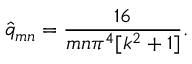<formula> <loc_0><loc_0><loc_500><loc_500>\hat { q } _ { m n } = \frac { 1 6 } { m n \pi ^ { 4 } [ k ^ { 2 } + 1 ] } .</formula> 